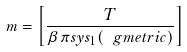Convert formula to latex. <formula><loc_0><loc_0><loc_500><loc_500>m = \left [ \frac { T } { \beta \pi s y s _ { 1 } ( \ g m e t r i c ) } \right ]</formula> 